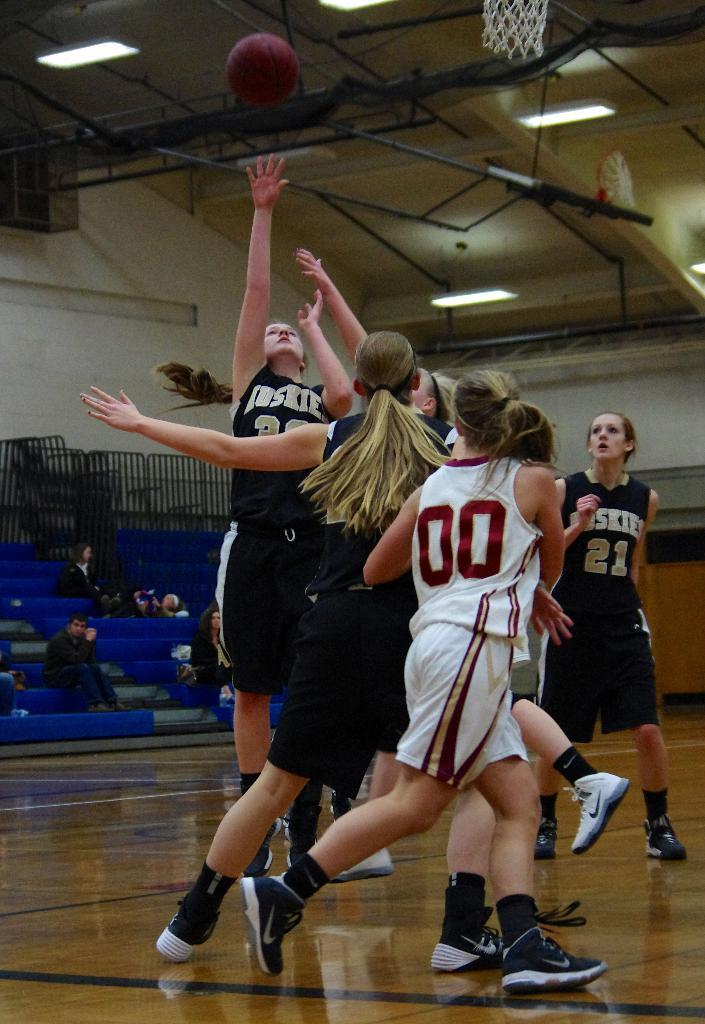Provide a one-sentence caption for the provided image. Women in Huskies uniforms playing basketball against a team in white uniforms. 